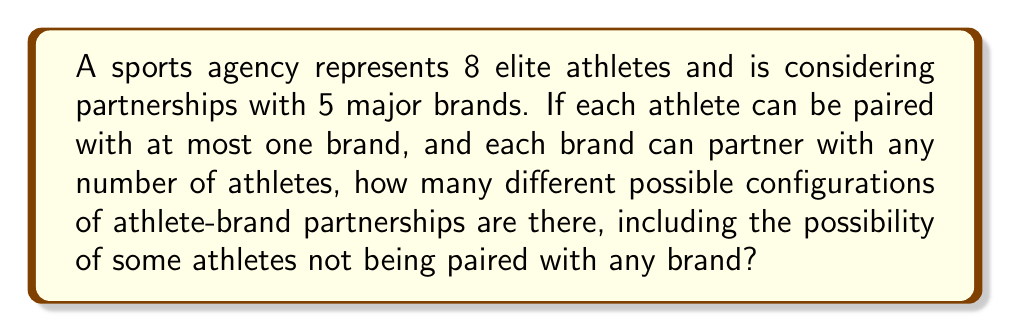Could you help me with this problem? Let's approach this step-by-step:

1) For each athlete, we have 6 options: they can be paired with one of the 5 brands, or they can remain unpaired.

2) This scenario can be represented as a function from the set of athletes to the set of brands plus an additional option for "no brand".

3) The number of such functions is given by the formula:

   $$(n+1)^m$$

   Where $n$ is the number of brands and $m$ is the number of athletes.

4) In this case:
   $n = 5$ (number of brands)
   $m = 8$ (number of athletes)

5) Plugging these values into our formula:

   $$(5+1)^8 = 6^8$$

6) Calculating this:

   $$6^8 = 1,679,616$$

Therefore, there are 1,679,616 different possible configurations of athlete-brand partnerships.
Answer: $$1,679,616$$ 